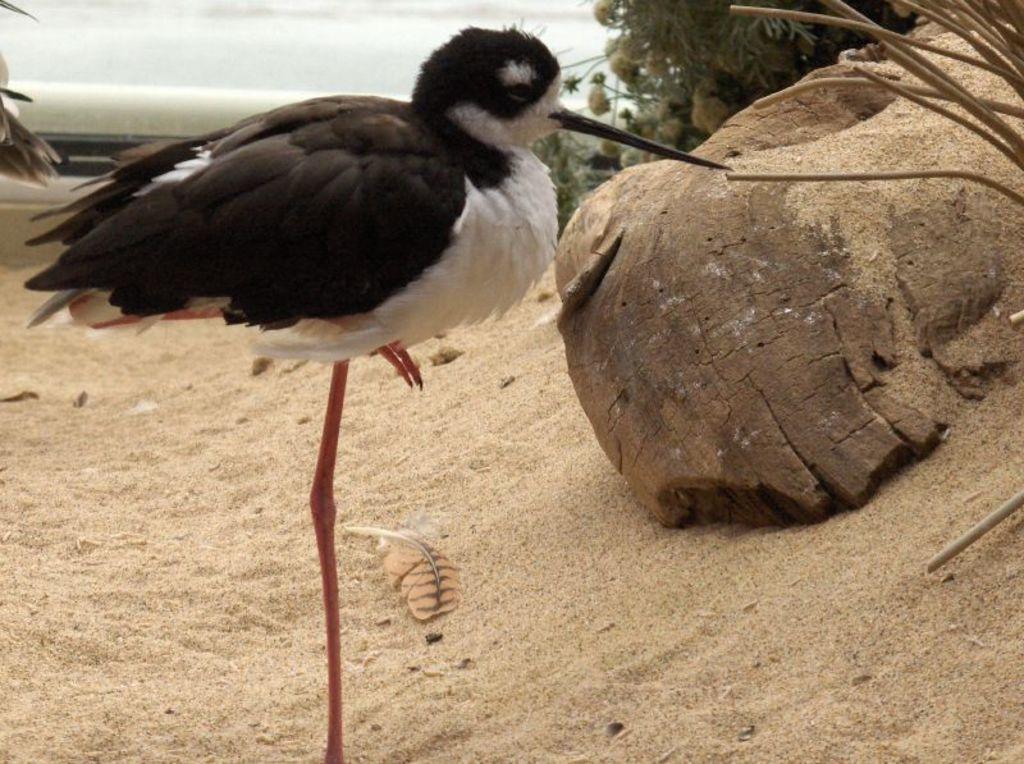Can you describe this image briefly? In this picture I can see a bird standing in front and I see that, it is of white and black color. I can also see the sand and few plants in the background. 